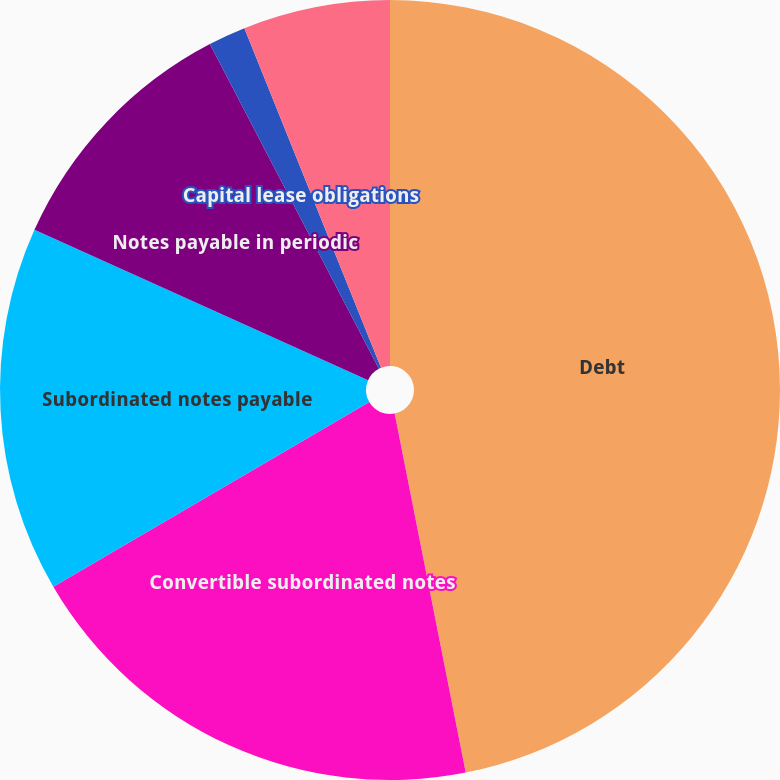Convert chart. <chart><loc_0><loc_0><loc_500><loc_500><pie_chart><fcel>Debt<fcel>Convertible subordinated notes<fcel>Subordinated notes payable<fcel>Notes payable in periodic<fcel>Capital lease obligations<fcel>Less current portion<nl><fcel>46.89%<fcel>19.69%<fcel>15.16%<fcel>10.62%<fcel>1.55%<fcel>6.09%<nl></chart> 